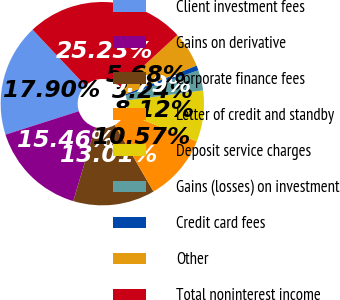Convert chart to OTSL. <chart><loc_0><loc_0><loc_500><loc_500><pie_chart><fcel>Client investment fees<fcel>Gains on derivative<fcel>Corporate finance fees<fcel>Letter of credit and standby<fcel>Deposit service charges<fcel>Gains (losses) on investment<fcel>Credit card fees<fcel>Other<fcel>Total noninterest income<nl><fcel>17.9%<fcel>15.46%<fcel>13.01%<fcel>10.57%<fcel>8.12%<fcel>3.24%<fcel>0.79%<fcel>5.68%<fcel>25.23%<nl></chart> 